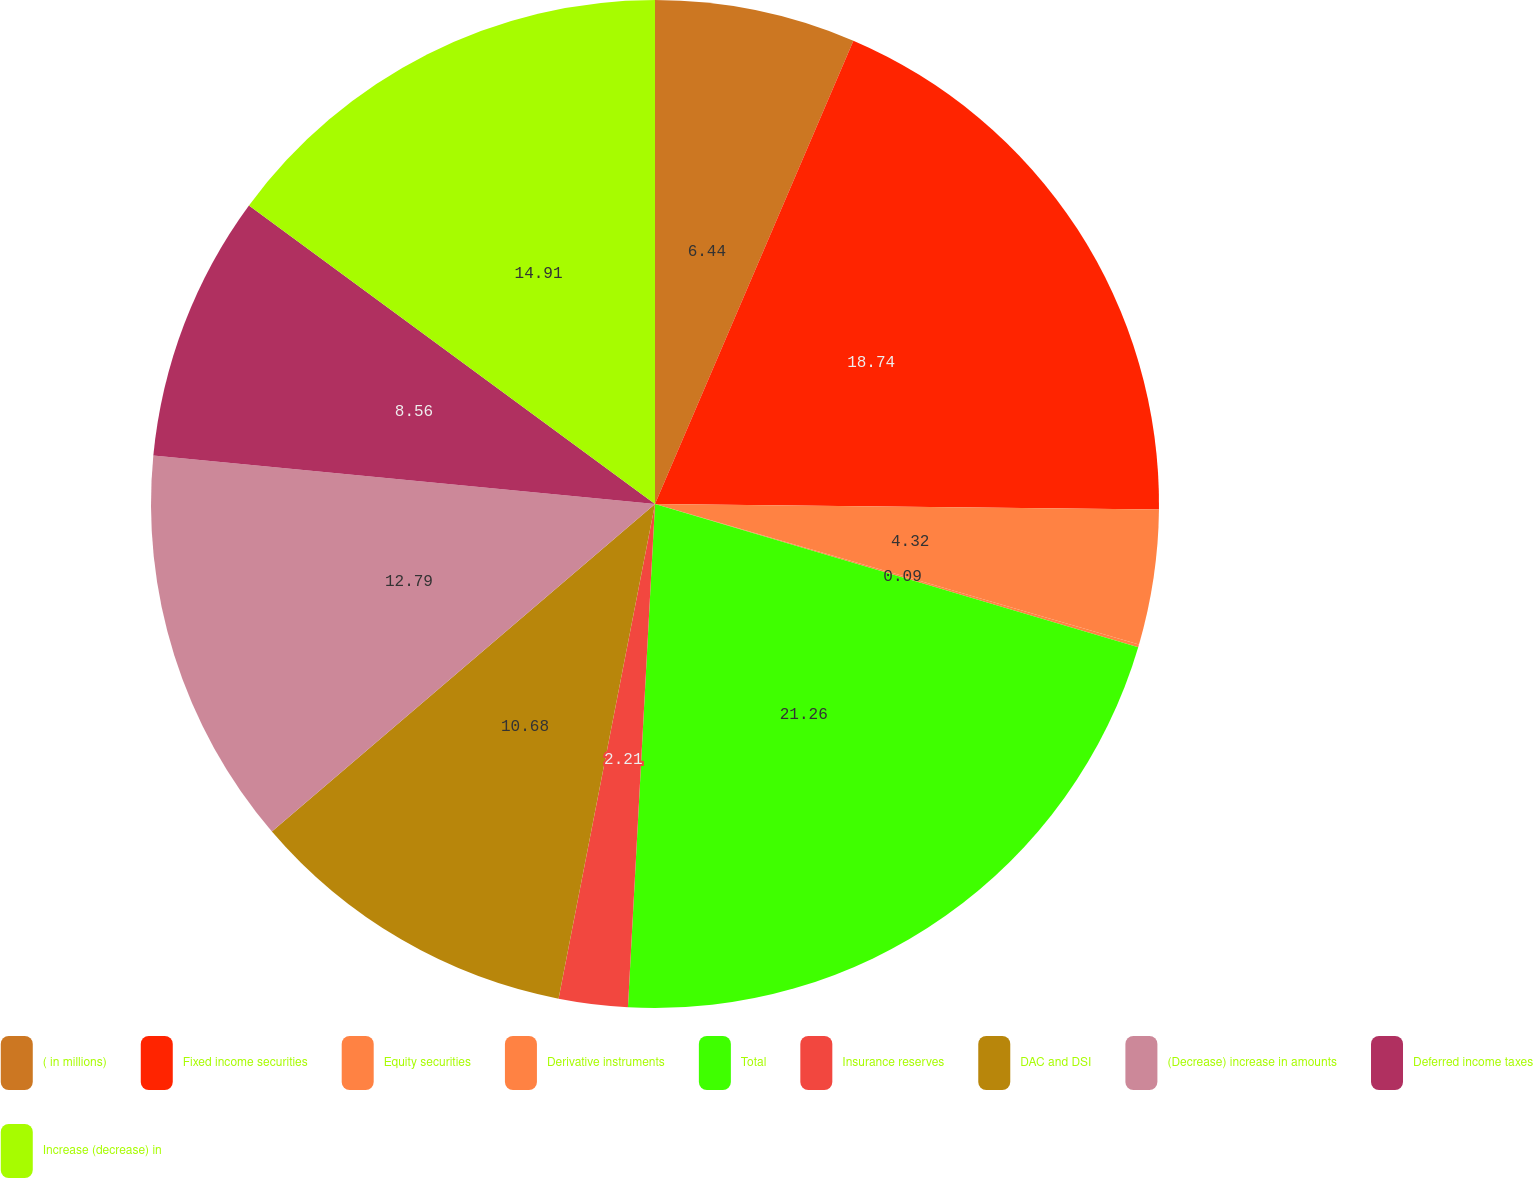Convert chart to OTSL. <chart><loc_0><loc_0><loc_500><loc_500><pie_chart><fcel>( in millions)<fcel>Fixed income securities<fcel>Equity securities<fcel>Derivative instruments<fcel>Total<fcel>Insurance reserves<fcel>DAC and DSI<fcel>(Decrease) increase in amounts<fcel>Deferred income taxes<fcel>Increase (decrease) in<nl><fcel>6.44%<fcel>18.74%<fcel>4.32%<fcel>0.09%<fcel>21.27%<fcel>2.21%<fcel>10.68%<fcel>12.79%<fcel>8.56%<fcel>14.91%<nl></chart> 